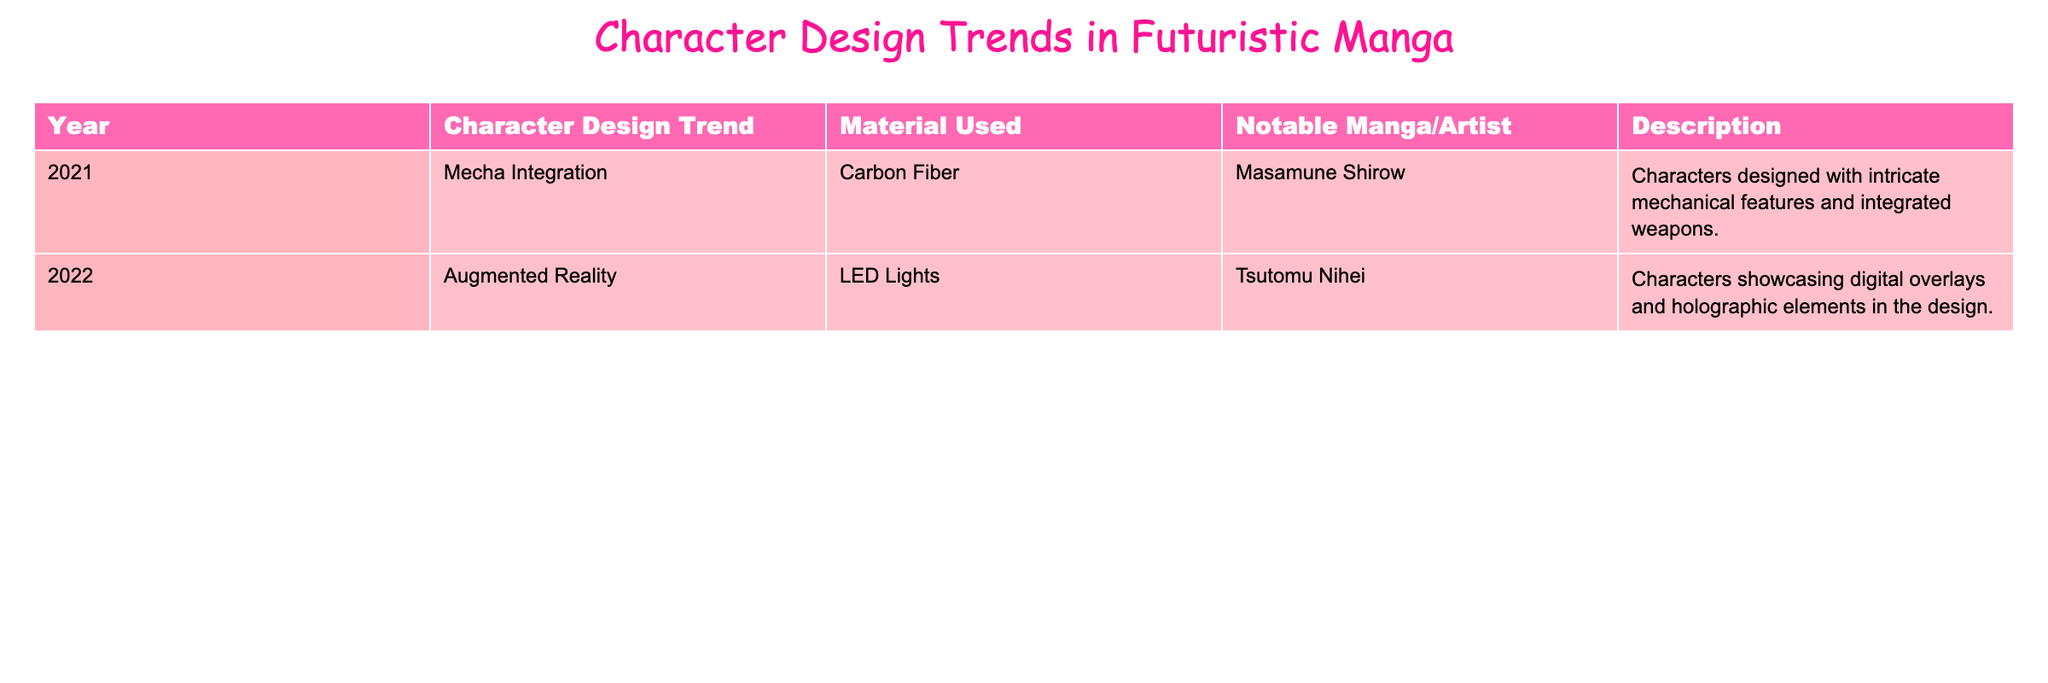What character design trend was noted for 2022? The table lists "Augmented Reality" as the character design trend for the year 2022.
Answer: Augmented Reality What material was used in the 2021 character designs? For the year 2021, the material used was "Carbon Fiber" according to the table.
Answer: Carbon Fiber Which notable manga artist is associated with the 2022 design trend? The table shows that Tsutomu Nihei is the notable manga artist linked to the 2022 trend of "Augmented Reality."
Answer: Tsutomu Nihei How many character design trends are listed in the table? The table includes two distinct character design trends for the years 2021 and 2022, indicating a total of two trends.
Answer: 2 Is "LED Lights" mentioned as a material used for character designs in 2021? The table indicates that "LED Lights" is associated with the year 2022, not 2021, making the statement false.
Answer: No What difference can be observed in the materials used from 2021 to 2022? Comparing the two years, "Carbon Fiber" was used in 2021, while "LED Lights" was utilized in 2022, indicating a shift from a solid to a more dynamic material.
Answer: Shift from Carbon Fiber to LED Lights Which design trend includes elements like holographic features? The "Augmented Reality" trend in 2022, as noted in the table, showcases digital overlays and holographic elements in character design.
Answer: Augmented Reality Calculate the total number of notable artists mentioned in the table. The table lists one notable artist for each year: Masamune Shirow for 2021 and Tsutomu Nihei for 2022, resulting in a total of two notable artists.
Answer: 2 Is Masamune Shirow associated with the "Augmented Reality" trend? The table associates Masamune Shirow with the "Mecha Integration" trend in 2021, making the statement false regarding "Augmented Reality."
Answer: No What is a common theme between the materials used in both years? Both materials, "Carbon Fiber" and "LED Lights," reflect advancements in technology, with one focusing on strength and the other on illumination and interactivity.
Answer: Advances in technology 